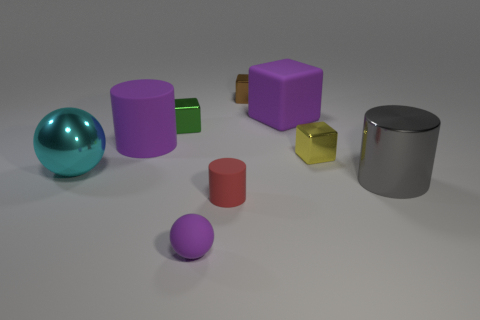Subtract all red spheres. Subtract all blue cubes. How many spheres are left? 2 Subtract all balls. How many objects are left? 7 Subtract 1 gray cylinders. How many objects are left? 8 Subtract all tiny green shiny cylinders. Subtract all brown things. How many objects are left? 8 Add 5 big purple matte blocks. How many big purple matte blocks are left? 6 Add 2 metallic blocks. How many metallic blocks exist? 5 